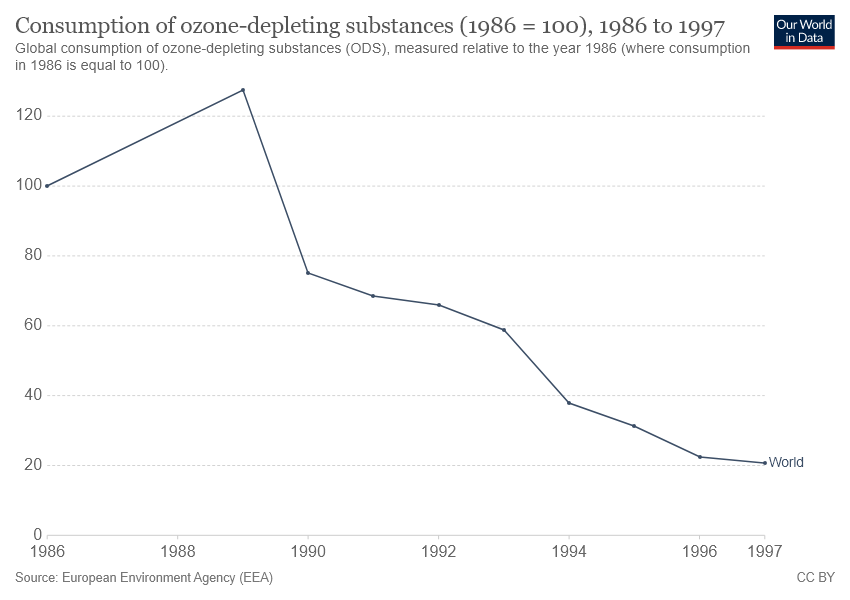Point out several critical features in this image. The line increased during the period of 1986 and 1989. The line reached its peak in 1989. 